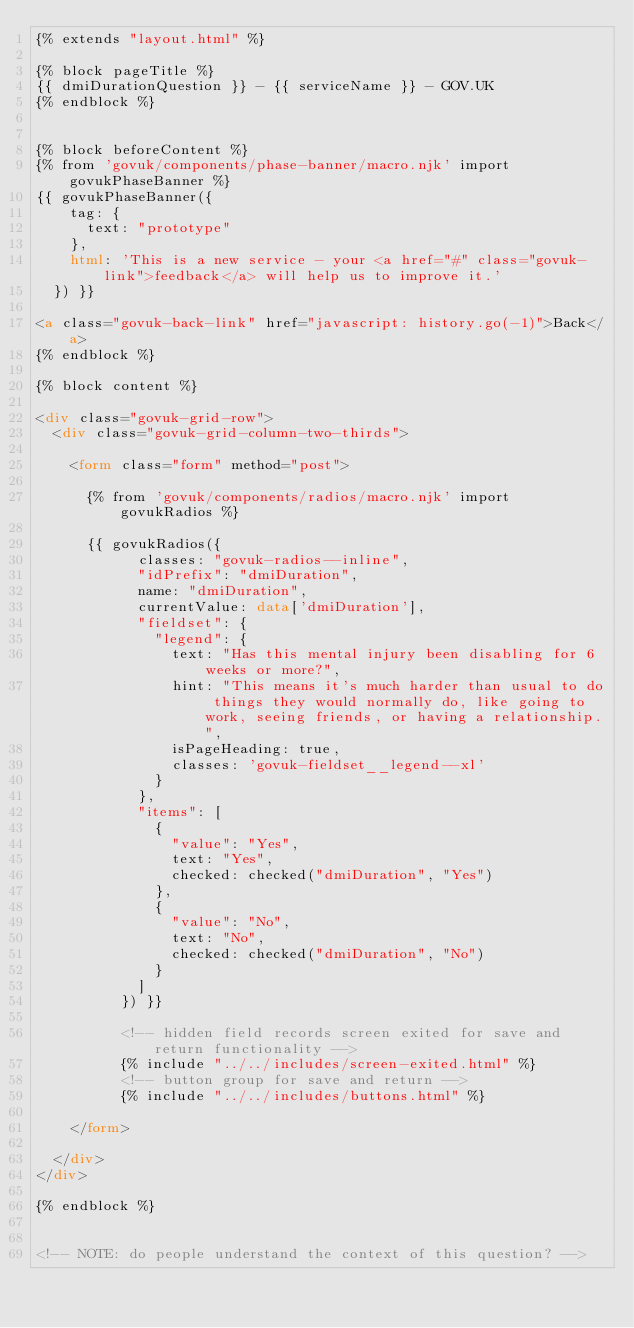Convert code to text. <code><loc_0><loc_0><loc_500><loc_500><_HTML_>{% extends "layout.html" %}

{% block pageTitle %}
{{ dmiDurationQuestion }} - {{ serviceName }} - GOV.UK
{% endblock %}


{% block beforeContent %}
{% from 'govuk/components/phase-banner/macro.njk' import govukPhaseBanner %}
{{ govukPhaseBanner({
    tag: {
      text: "prototype"
    },
    html: 'This is a new service - your <a href="#" class="govuk-link">feedback</a> will help us to improve it.'
  }) }}

<a class="govuk-back-link" href="javascript: history.go(-1)">Back</a>
{% endblock %}

{% block content %}

<div class="govuk-grid-row">
  <div class="govuk-grid-column-two-thirds">

    <form class="form" method="post">

      {% from 'govuk/components/radios/macro.njk' import govukRadios %}

      {{ govukRadios({
            classes: "govuk-radios--inline",
            "idPrefix": "dmiDuration",
            name: "dmiDuration",
            currentValue: data['dmiDuration'],
            "fieldset": {
              "legend": {
                text: "Has this mental injury been disabling for 6 weeks or more?",
                hint: "This means it's much harder than usual to do things they would normally do, like going to work, seeing friends, or having a relationship.",
                isPageHeading: true,
                classes: 'govuk-fieldset__legend--xl'
              }
            },
            "items": [
              {
                "value": "Yes",
                text: "Yes",
                checked: checked("dmiDuration", "Yes")
              },
              {
                "value": "No",
                text: "No",
                checked: checked("dmiDuration", "No")
              }
            ]
          }) }}

          <!-- hidden field records screen exited for save and return functionality -->
          {% include "../../includes/screen-exited.html" %}
          <!-- button group for save and return -->
          {% include "../../includes/buttons.html" %}

    </form>

  </div>
</div>

{% endblock %}


<!-- NOTE: do people understand the context of this question? -->
</code> 